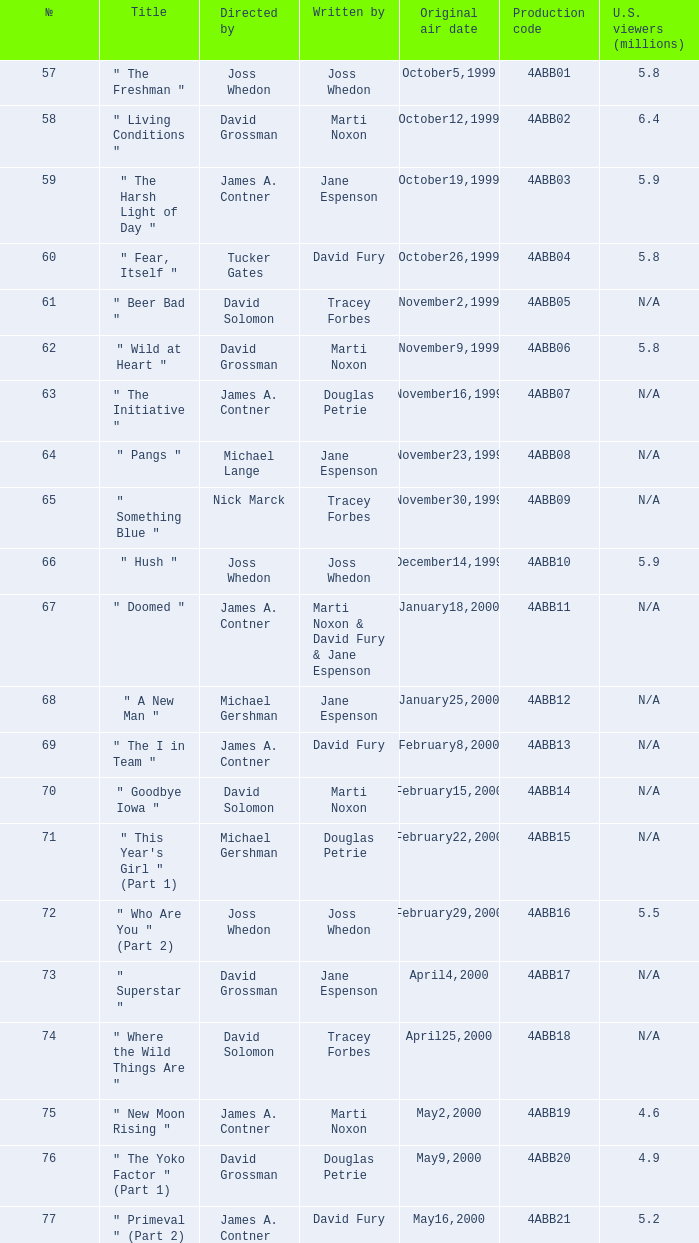What is the title of episode No. 65? " Something Blue ". 